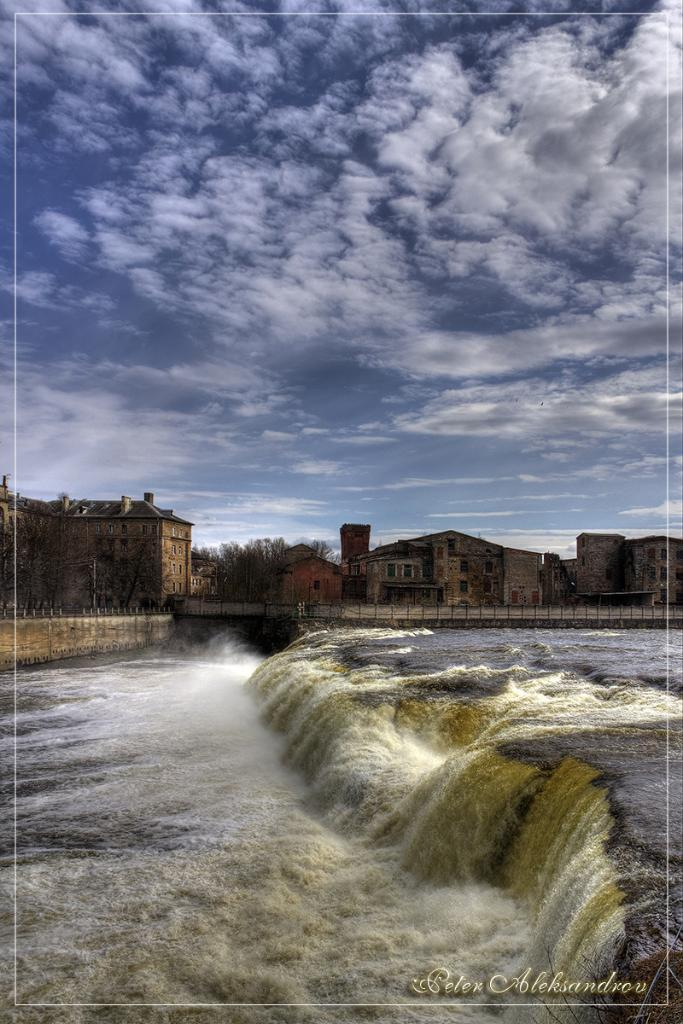What is the primary element present in the image? There is water in the image. What structure can be seen crossing over the water? There is a bridge in the image. What type of man-made structures are visible in the image? There are buildings in the image. What type of natural elements are present in the image? There are trees in the image. What type of vertical structures are present in the image? There are poles in the image. What can be seen in the background of the image? The sky is visible in the background of the image. What type of van can be seen parked near the bridge in the image? There is no van present in the image; only water, a bridge, buildings, trees, poles, and the sky are visible. What type of cable is being used to support the bridge in the image? The image does not show any cables supporting the bridge; it only shows the bridge itself. 